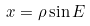Convert formula to latex. <formula><loc_0><loc_0><loc_500><loc_500>x = \rho \sin E</formula> 